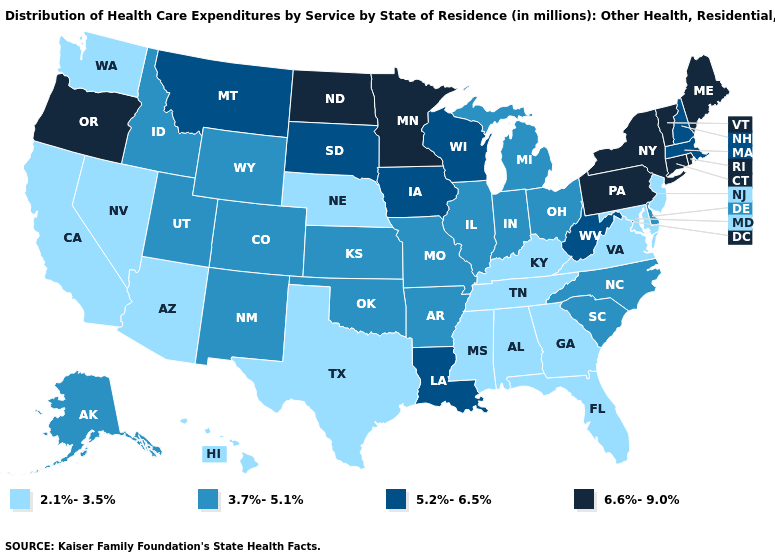What is the value of Ohio?
Short answer required. 3.7%-5.1%. What is the value of Nevada?
Answer briefly. 2.1%-3.5%. Name the states that have a value in the range 6.6%-9.0%?
Give a very brief answer. Connecticut, Maine, Minnesota, New York, North Dakota, Oregon, Pennsylvania, Rhode Island, Vermont. Is the legend a continuous bar?
Concise answer only. No. What is the value of Arizona?
Short answer required. 2.1%-3.5%. What is the value of Kansas?
Short answer required. 3.7%-5.1%. What is the value of South Carolina?
Concise answer only. 3.7%-5.1%. Name the states that have a value in the range 5.2%-6.5%?
Keep it brief. Iowa, Louisiana, Massachusetts, Montana, New Hampshire, South Dakota, West Virginia, Wisconsin. Is the legend a continuous bar?
Concise answer only. No. What is the value of Vermont?
Short answer required. 6.6%-9.0%. Name the states that have a value in the range 6.6%-9.0%?
Short answer required. Connecticut, Maine, Minnesota, New York, North Dakota, Oregon, Pennsylvania, Rhode Island, Vermont. Is the legend a continuous bar?
Short answer required. No. Name the states that have a value in the range 6.6%-9.0%?
Write a very short answer. Connecticut, Maine, Minnesota, New York, North Dakota, Oregon, Pennsylvania, Rhode Island, Vermont. Does New York have a lower value than New Mexico?
Concise answer only. No. 